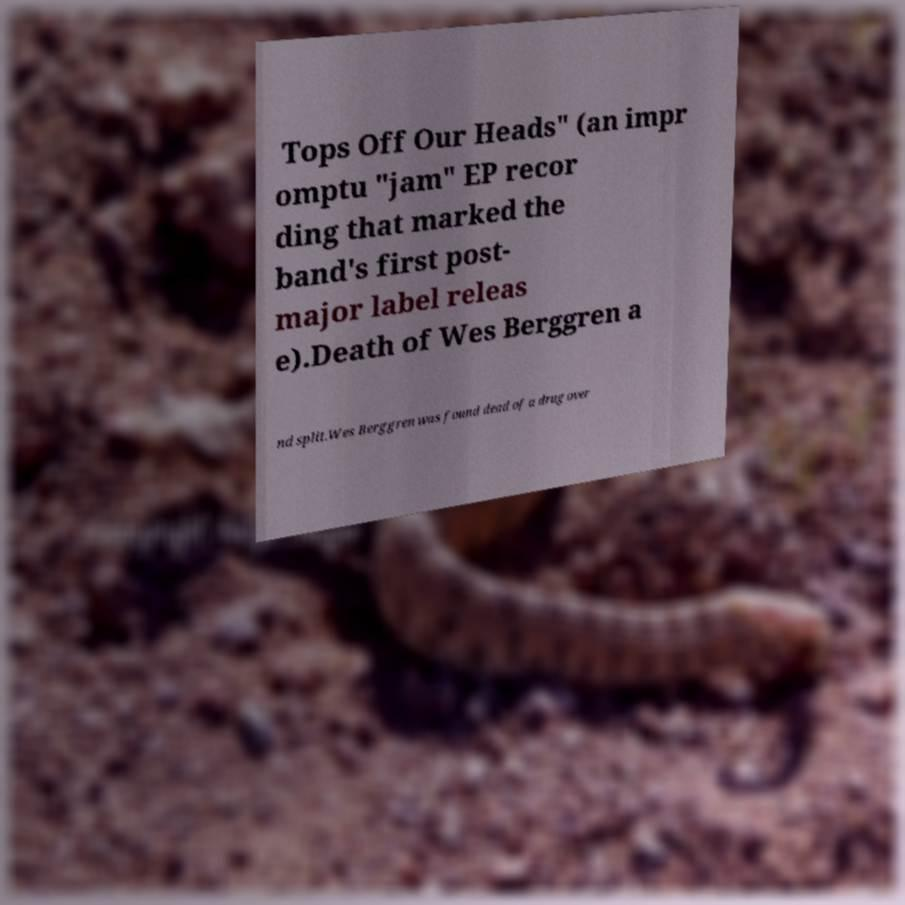Please identify and transcribe the text found in this image. Tops Off Our Heads" (an impr omptu "jam" EP recor ding that marked the band's first post- major label releas e).Death of Wes Berggren a nd split.Wes Berggren was found dead of a drug over 